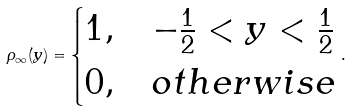<formula> <loc_0><loc_0><loc_500><loc_500>\rho _ { \infty } ( y ) = \begin{cases} 1 , & - \frac { 1 } { 2 } < y < \frac { 1 } { 2 } \\ 0 , & o t h e r w i s e \end{cases} .</formula> 